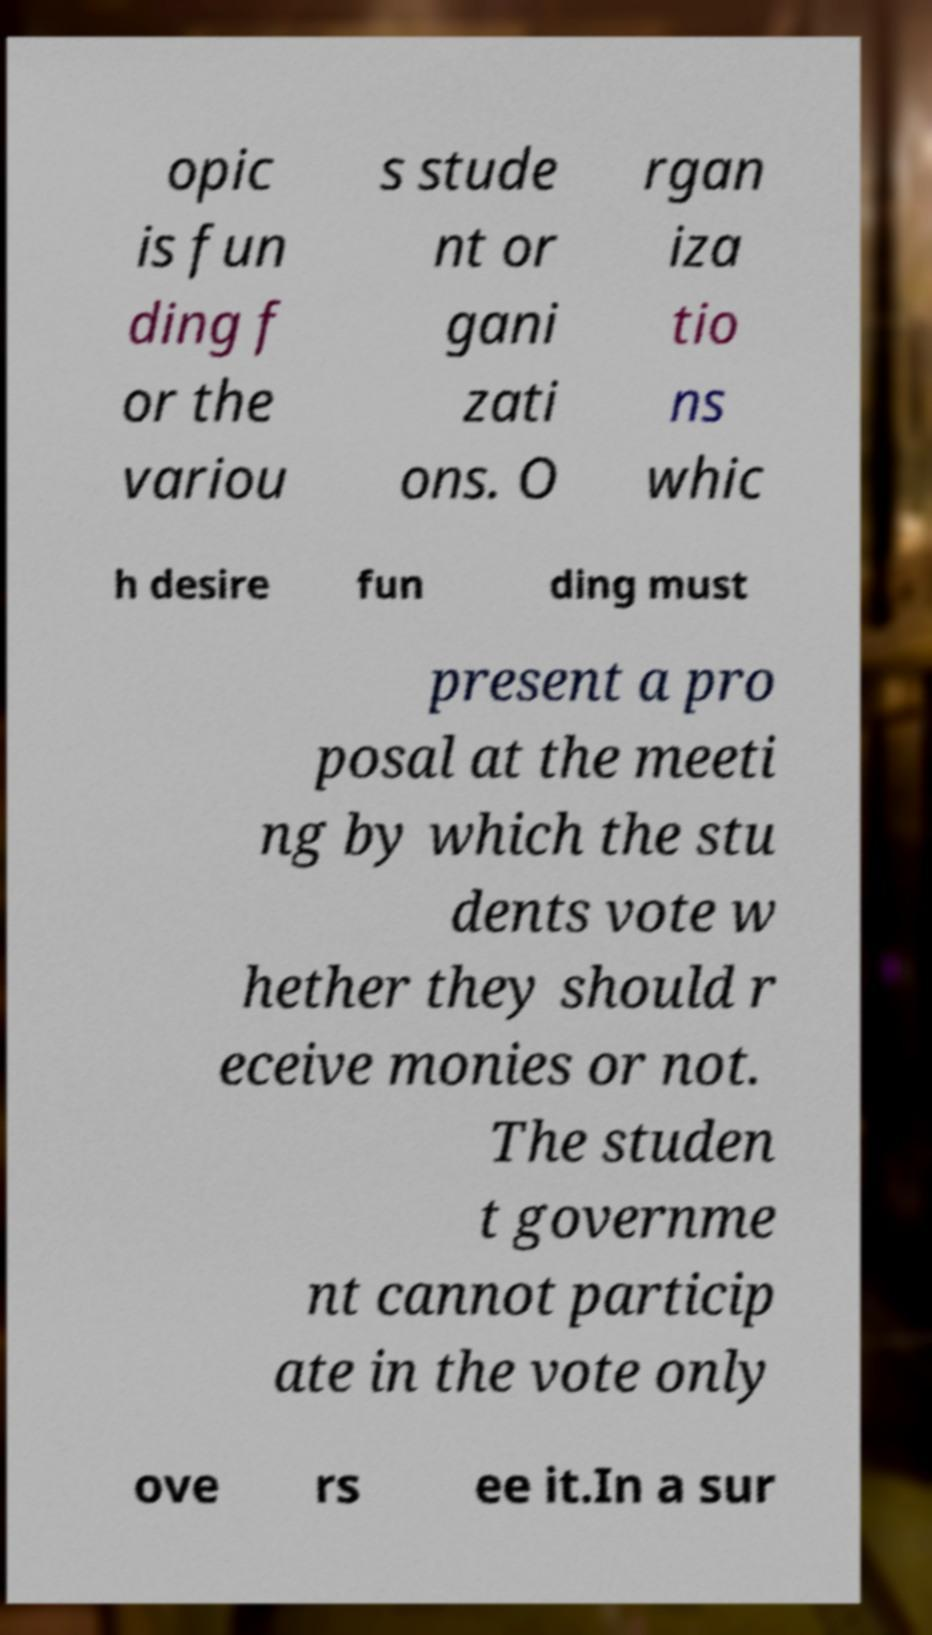Can you accurately transcribe the text from the provided image for me? opic is fun ding f or the variou s stude nt or gani zati ons. O rgan iza tio ns whic h desire fun ding must present a pro posal at the meeti ng by which the stu dents vote w hether they should r eceive monies or not. The studen t governme nt cannot particip ate in the vote only ove rs ee it.In a sur 